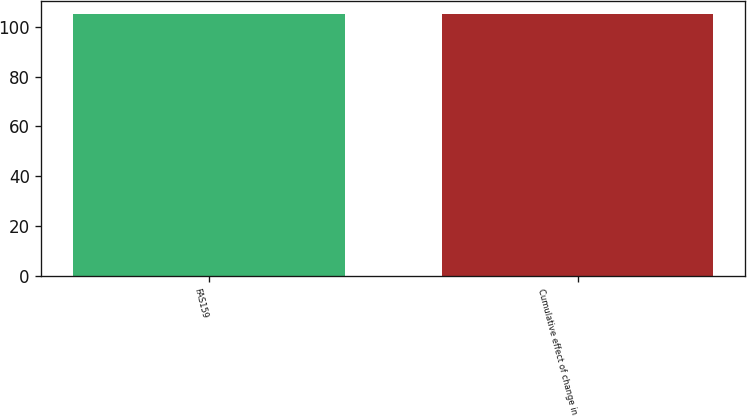Convert chart. <chart><loc_0><loc_0><loc_500><loc_500><bar_chart><fcel>FAS159<fcel>Cumulative effect of change in<nl><fcel>105<fcel>105.1<nl></chart> 